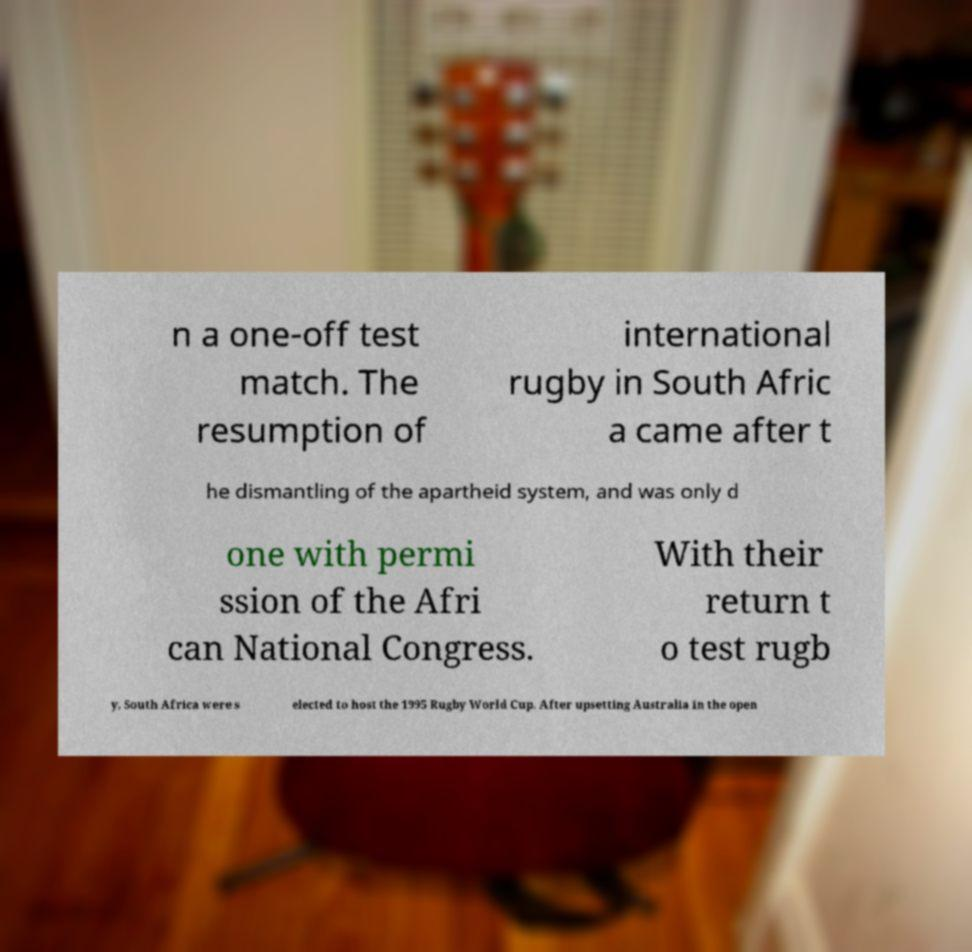Could you assist in decoding the text presented in this image and type it out clearly? n a one-off test match. The resumption of international rugby in South Afric a came after t he dismantling of the apartheid system, and was only d one with permi ssion of the Afri can National Congress. With their return t o test rugb y, South Africa were s elected to host the 1995 Rugby World Cup. After upsetting Australia in the open 